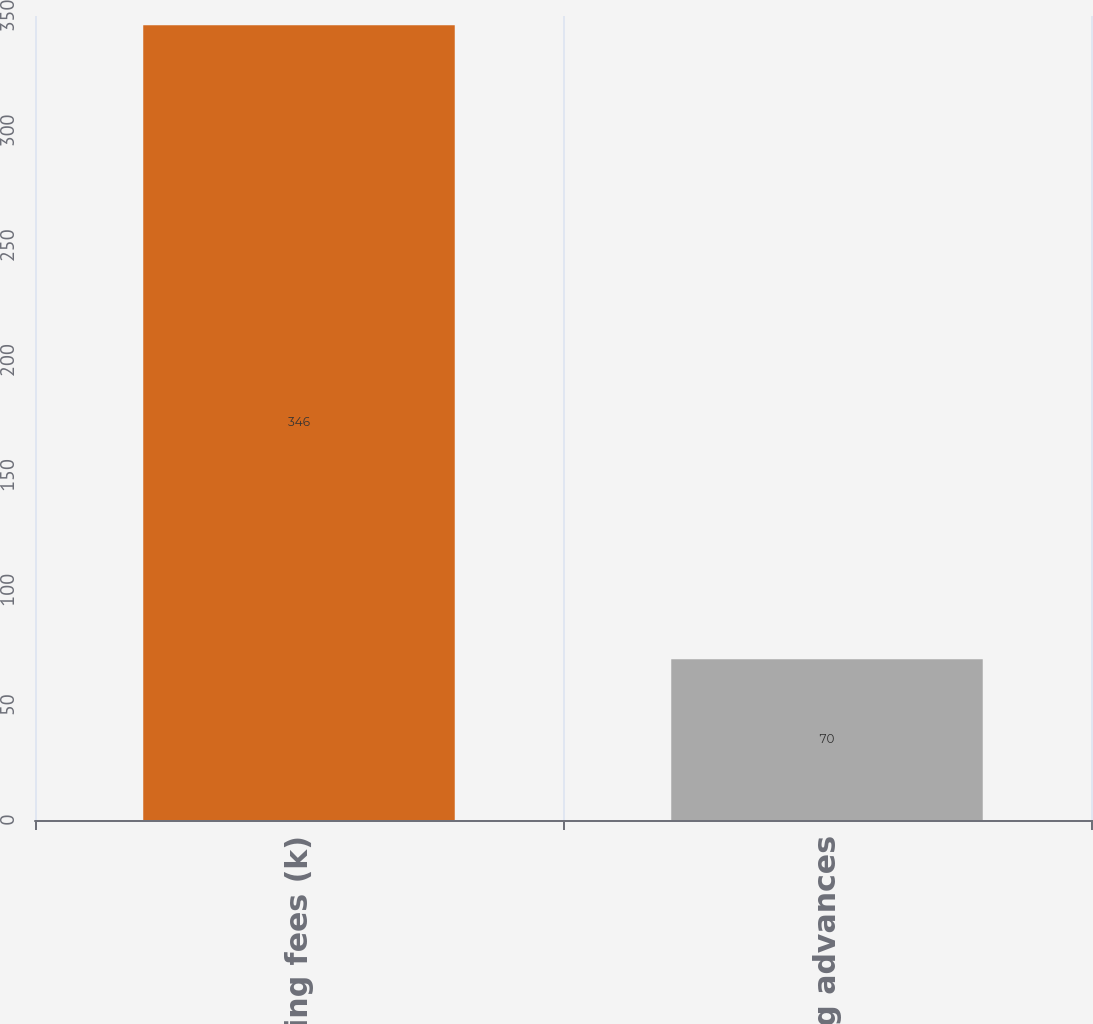Convert chart. <chart><loc_0><loc_0><loc_500><loc_500><bar_chart><fcel>Servicing fees (k)<fcel>Servicing advances<nl><fcel>346<fcel>70<nl></chart> 